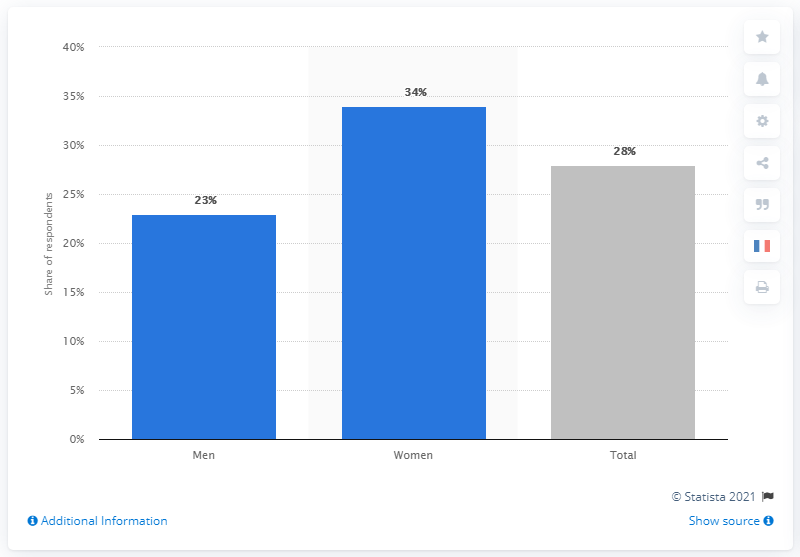Which group shows the highest level of concern about Coronavirus according to this data? Women show the highest level of concern about Coronavirus, as reflected by the highest percentage of 34% among the groups featured in the chart. 